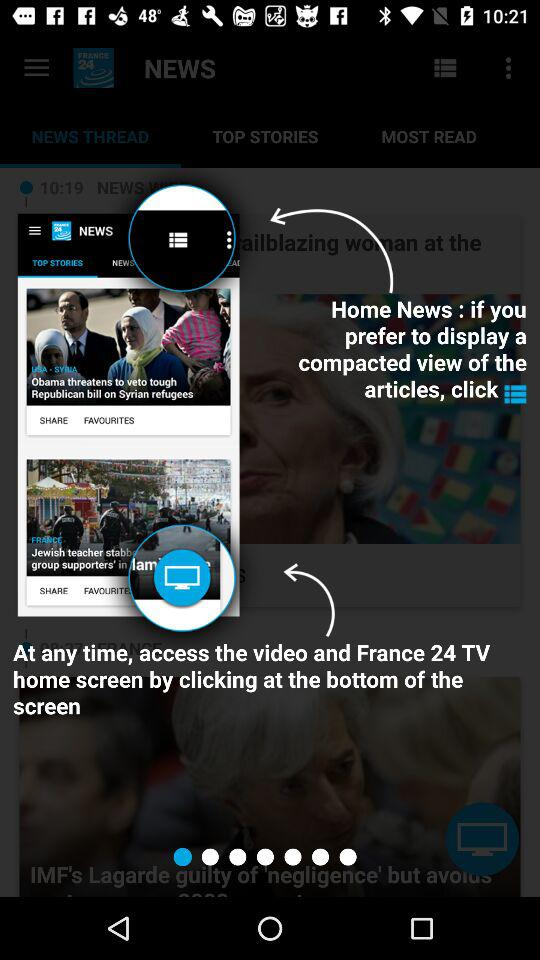What is the name of the application? The application name is "FRANCE 24". 